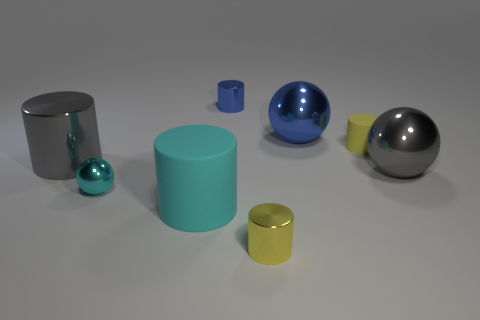There is a large thing that is both on the right side of the gray shiny cylinder and behind the large gray metallic sphere; what is it made of?
Make the answer very short. Metal. Is there any other thing that has the same size as the blue cylinder?
Give a very brief answer. Yes. Is the small sphere the same color as the large rubber cylinder?
Provide a short and direct response. Yes. There is a matte thing that is the same color as the small sphere; what shape is it?
Ensure brevity in your answer.  Cylinder. How many other tiny metallic objects are the same shape as the yellow shiny object?
Your answer should be compact. 1. There is a blue cylinder that is made of the same material as the tiny sphere; what is its size?
Provide a short and direct response. Small. Does the gray shiny cylinder have the same size as the cyan cylinder?
Your answer should be very brief. Yes. Are there any tiny blue cylinders?
Provide a succinct answer. Yes. What is the size of the ball that is the same color as the large matte thing?
Your answer should be compact. Small. There is a yellow thing in front of the large gray metallic thing on the left side of the gray metal object that is in front of the large gray metallic cylinder; what size is it?
Your response must be concise. Small. 